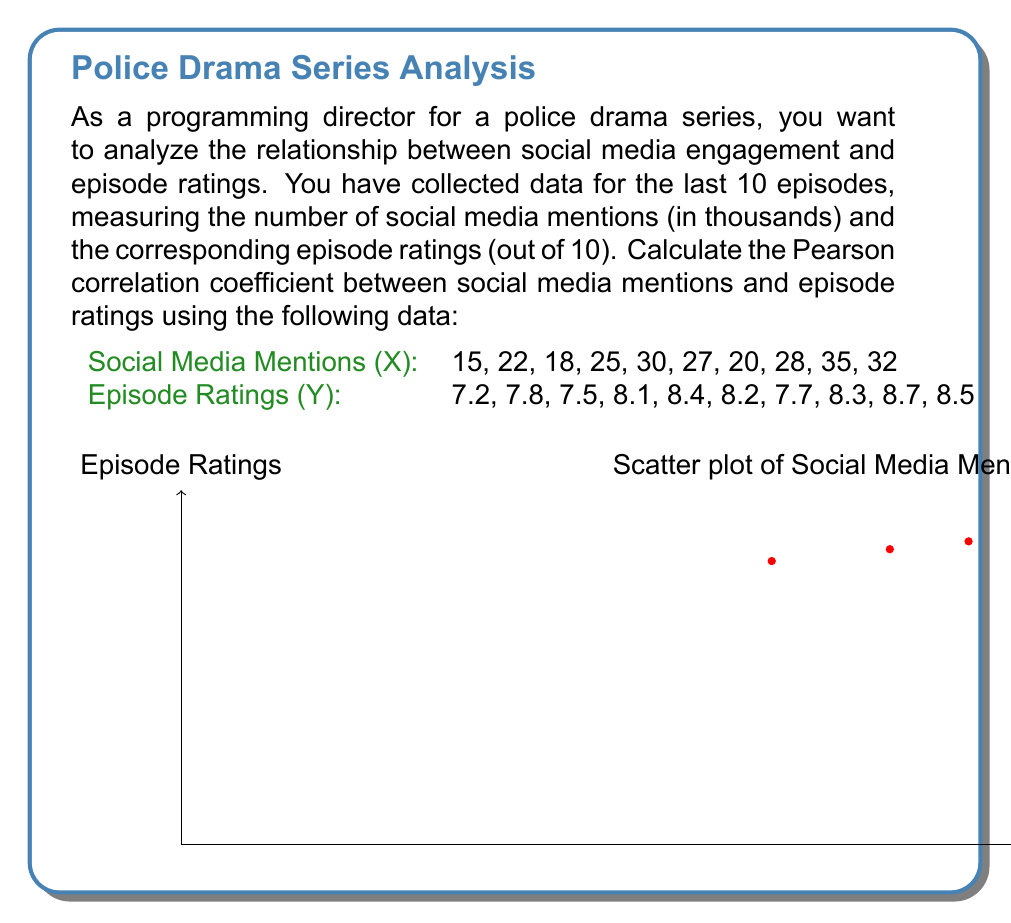Help me with this question. To calculate the Pearson correlation coefficient (r) between social media mentions (X) and episode ratings (Y), we'll follow these steps:

1. Calculate the means of X and Y:
   $\bar{X} = \frac{\sum X}{n} = \frac{252}{10} = 25.2$
   $\bar{Y} = \frac{\sum Y}{n} = \frac{80.4}{10} = 8.04$

2. Calculate the deviations from the mean for X and Y:
   $x_i = X_i - \bar{X}$
   $y_i = Y_i - \bar{Y}$

3. Calculate the products of the deviations:
   $x_i y_i$

4. Calculate the squares of the deviations:
   $x_i^2$ and $y_i^2$

5. Sum up the products and squares:
   $\sum x_i y_i$, $\sum x_i^2$, and $\sum y_i^2$

6. Apply the formula for Pearson correlation coefficient:

   $$r = \frac{\sum x_i y_i}{\sqrt{\sum x_i^2 \sum y_i^2}}$$

Calculations:
$\sum x_i y_i = 36.72$
$\sum x_i^2 = 680.4$
$\sum y_i^2 = 1.8676$

Substituting into the formula:

$$r = \frac{36.72}{\sqrt{680.4 \times 1.8676}} = \frac{36.72}{\sqrt{1270.58}} = \frac{36.72}{35.64} \approx 0.9741$$

The Pearson correlation coefficient is approximately 0.9741, indicating a very strong positive correlation between social media mentions and episode ratings.
Answer: $r \approx 0.9741$ 